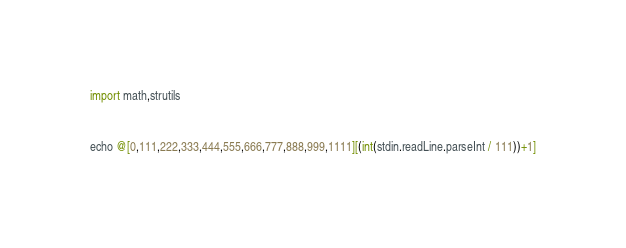<code> <loc_0><loc_0><loc_500><loc_500><_Nim_>import math,strutils


echo @[0,111,222,333,444,555,666,777,888,999,1111][(int(stdin.readLine.parseInt / 111))+1]</code> 